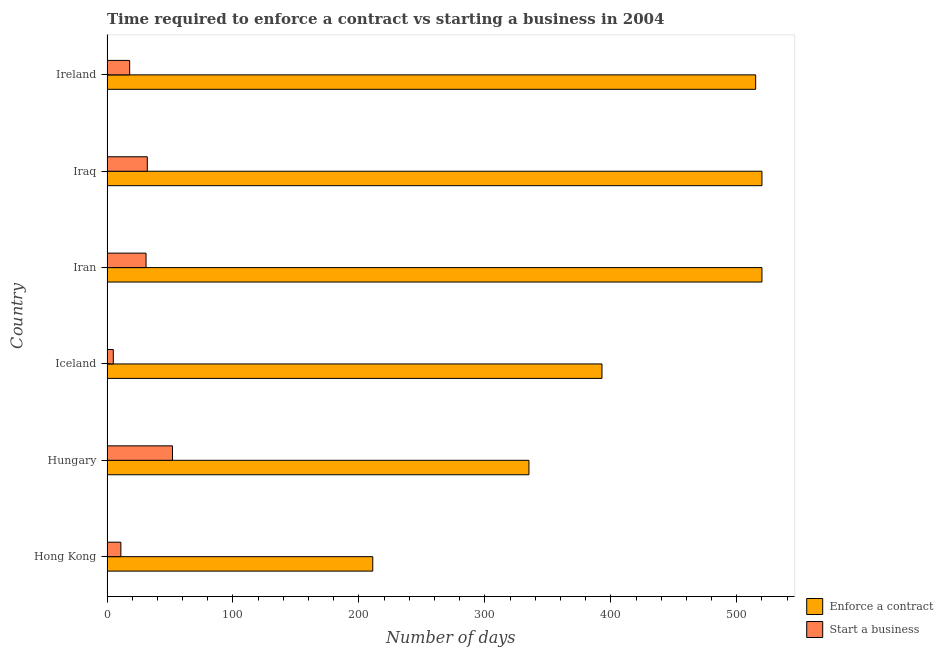How many groups of bars are there?
Your answer should be compact. 6. How many bars are there on the 6th tick from the bottom?
Your answer should be very brief. 2. What is the label of the 5th group of bars from the top?
Make the answer very short. Hungary. Across all countries, what is the maximum number of days to enforece a contract?
Ensure brevity in your answer.  520. Across all countries, what is the minimum number of days to enforece a contract?
Your answer should be compact. 211. In which country was the number of days to start a business maximum?
Provide a succinct answer. Hungary. In which country was the number of days to enforece a contract minimum?
Ensure brevity in your answer.  Hong Kong. What is the total number of days to enforece a contract in the graph?
Keep it short and to the point. 2494. What is the difference between the number of days to start a business in Iceland and the number of days to enforece a contract in Iraq?
Make the answer very short. -515. What is the average number of days to enforece a contract per country?
Keep it short and to the point. 415.67. What is the difference between the number of days to start a business and number of days to enforece a contract in Iceland?
Offer a very short reply. -388. In how many countries, is the number of days to start a business greater than 500 days?
Your answer should be compact. 0. What is the ratio of the number of days to enforece a contract in Hong Kong to that in Iran?
Ensure brevity in your answer.  0.41. Is the number of days to start a business in Iceland less than that in Iraq?
Make the answer very short. Yes. In how many countries, is the number of days to start a business greater than the average number of days to start a business taken over all countries?
Give a very brief answer. 3. Is the sum of the number of days to start a business in Hong Kong and Iceland greater than the maximum number of days to enforece a contract across all countries?
Provide a short and direct response. No. What does the 1st bar from the top in Hungary represents?
Ensure brevity in your answer.  Start a business. What does the 2nd bar from the bottom in Hungary represents?
Provide a short and direct response. Start a business. How many bars are there?
Your response must be concise. 12. Are all the bars in the graph horizontal?
Ensure brevity in your answer.  Yes. What is the difference between two consecutive major ticks on the X-axis?
Your answer should be very brief. 100. Are the values on the major ticks of X-axis written in scientific E-notation?
Ensure brevity in your answer.  No. Does the graph contain grids?
Give a very brief answer. No. Where does the legend appear in the graph?
Your answer should be compact. Bottom right. How are the legend labels stacked?
Provide a succinct answer. Vertical. What is the title of the graph?
Offer a very short reply. Time required to enforce a contract vs starting a business in 2004. Does "Overweight" appear as one of the legend labels in the graph?
Give a very brief answer. No. What is the label or title of the X-axis?
Your answer should be very brief. Number of days. What is the Number of days in Enforce a contract in Hong Kong?
Your answer should be compact. 211. What is the Number of days of Enforce a contract in Hungary?
Make the answer very short. 335. What is the Number of days in Start a business in Hungary?
Your answer should be very brief. 52. What is the Number of days in Enforce a contract in Iceland?
Provide a short and direct response. 393. What is the Number of days in Enforce a contract in Iran?
Ensure brevity in your answer.  520. What is the Number of days in Start a business in Iran?
Your response must be concise. 31. What is the Number of days in Enforce a contract in Iraq?
Offer a terse response. 520. What is the Number of days in Start a business in Iraq?
Provide a succinct answer. 32. What is the Number of days of Enforce a contract in Ireland?
Your response must be concise. 515. What is the Number of days in Start a business in Ireland?
Offer a terse response. 18. Across all countries, what is the maximum Number of days of Enforce a contract?
Give a very brief answer. 520. Across all countries, what is the minimum Number of days of Enforce a contract?
Provide a succinct answer. 211. What is the total Number of days of Enforce a contract in the graph?
Keep it short and to the point. 2494. What is the total Number of days of Start a business in the graph?
Offer a very short reply. 149. What is the difference between the Number of days in Enforce a contract in Hong Kong and that in Hungary?
Your answer should be very brief. -124. What is the difference between the Number of days of Start a business in Hong Kong and that in Hungary?
Keep it short and to the point. -41. What is the difference between the Number of days in Enforce a contract in Hong Kong and that in Iceland?
Ensure brevity in your answer.  -182. What is the difference between the Number of days of Start a business in Hong Kong and that in Iceland?
Offer a terse response. 6. What is the difference between the Number of days in Enforce a contract in Hong Kong and that in Iran?
Provide a short and direct response. -309. What is the difference between the Number of days of Enforce a contract in Hong Kong and that in Iraq?
Ensure brevity in your answer.  -309. What is the difference between the Number of days in Enforce a contract in Hong Kong and that in Ireland?
Ensure brevity in your answer.  -304. What is the difference between the Number of days in Start a business in Hong Kong and that in Ireland?
Give a very brief answer. -7. What is the difference between the Number of days of Enforce a contract in Hungary and that in Iceland?
Ensure brevity in your answer.  -58. What is the difference between the Number of days of Enforce a contract in Hungary and that in Iran?
Provide a succinct answer. -185. What is the difference between the Number of days of Start a business in Hungary and that in Iran?
Provide a succinct answer. 21. What is the difference between the Number of days in Enforce a contract in Hungary and that in Iraq?
Offer a terse response. -185. What is the difference between the Number of days in Start a business in Hungary and that in Iraq?
Your answer should be compact. 20. What is the difference between the Number of days of Enforce a contract in Hungary and that in Ireland?
Offer a terse response. -180. What is the difference between the Number of days in Start a business in Hungary and that in Ireland?
Your response must be concise. 34. What is the difference between the Number of days of Enforce a contract in Iceland and that in Iran?
Ensure brevity in your answer.  -127. What is the difference between the Number of days of Enforce a contract in Iceland and that in Iraq?
Your answer should be very brief. -127. What is the difference between the Number of days of Enforce a contract in Iceland and that in Ireland?
Provide a short and direct response. -122. What is the difference between the Number of days in Start a business in Iceland and that in Ireland?
Your response must be concise. -13. What is the difference between the Number of days of Enforce a contract in Iran and that in Ireland?
Give a very brief answer. 5. What is the difference between the Number of days in Enforce a contract in Hong Kong and the Number of days in Start a business in Hungary?
Give a very brief answer. 159. What is the difference between the Number of days in Enforce a contract in Hong Kong and the Number of days in Start a business in Iceland?
Provide a short and direct response. 206. What is the difference between the Number of days of Enforce a contract in Hong Kong and the Number of days of Start a business in Iran?
Your response must be concise. 180. What is the difference between the Number of days of Enforce a contract in Hong Kong and the Number of days of Start a business in Iraq?
Provide a succinct answer. 179. What is the difference between the Number of days of Enforce a contract in Hong Kong and the Number of days of Start a business in Ireland?
Your answer should be very brief. 193. What is the difference between the Number of days of Enforce a contract in Hungary and the Number of days of Start a business in Iceland?
Give a very brief answer. 330. What is the difference between the Number of days of Enforce a contract in Hungary and the Number of days of Start a business in Iran?
Offer a very short reply. 304. What is the difference between the Number of days in Enforce a contract in Hungary and the Number of days in Start a business in Iraq?
Your answer should be compact. 303. What is the difference between the Number of days of Enforce a contract in Hungary and the Number of days of Start a business in Ireland?
Your answer should be compact. 317. What is the difference between the Number of days in Enforce a contract in Iceland and the Number of days in Start a business in Iran?
Make the answer very short. 362. What is the difference between the Number of days of Enforce a contract in Iceland and the Number of days of Start a business in Iraq?
Ensure brevity in your answer.  361. What is the difference between the Number of days in Enforce a contract in Iceland and the Number of days in Start a business in Ireland?
Make the answer very short. 375. What is the difference between the Number of days in Enforce a contract in Iran and the Number of days in Start a business in Iraq?
Your answer should be compact. 488. What is the difference between the Number of days of Enforce a contract in Iran and the Number of days of Start a business in Ireland?
Your answer should be compact. 502. What is the difference between the Number of days in Enforce a contract in Iraq and the Number of days in Start a business in Ireland?
Offer a terse response. 502. What is the average Number of days in Enforce a contract per country?
Your response must be concise. 415.67. What is the average Number of days of Start a business per country?
Offer a terse response. 24.83. What is the difference between the Number of days in Enforce a contract and Number of days in Start a business in Hungary?
Offer a terse response. 283. What is the difference between the Number of days of Enforce a contract and Number of days of Start a business in Iceland?
Give a very brief answer. 388. What is the difference between the Number of days of Enforce a contract and Number of days of Start a business in Iran?
Offer a terse response. 489. What is the difference between the Number of days in Enforce a contract and Number of days in Start a business in Iraq?
Your answer should be very brief. 488. What is the difference between the Number of days of Enforce a contract and Number of days of Start a business in Ireland?
Offer a terse response. 497. What is the ratio of the Number of days of Enforce a contract in Hong Kong to that in Hungary?
Your response must be concise. 0.63. What is the ratio of the Number of days of Start a business in Hong Kong to that in Hungary?
Your answer should be compact. 0.21. What is the ratio of the Number of days in Enforce a contract in Hong Kong to that in Iceland?
Provide a short and direct response. 0.54. What is the ratio of the Number of days of Enforce a contract in Hong Kong to that in Iran?
Provide a succinct answer. 0.41. What is the ratio of the Number of days in Start a business in Hong Kong to that in Iran?
Your response must be concise. 0.35. What is the ratio of the Number of days of Enforce a contract in Hong Kong to that in Iraq?
Your response must be concise. 0.41. What is the ratio of the Number of days in Start a business in Hong Kong to that in Iraq?
Make the answer very short. 0.34. What is the ratio of the Number of days of Enforce a contract in Hong Kong to that in Ireland?
Keep it short and to the point. 0.41. What is the ratio of the Number of days in Start a business in Hong Kong to that in Ireland?
Provide a short and direct response. 0.61. What is the ratio of the Number of days of Enforce a contract in Hungary to that in Iceland?
Give a very brief answer. 0.85. What is the ratio of the Number of days in Start a business in Hungary to that in Iceland?
Your response must be concise. 10.4. What is the ratio of the Number of days of Enforce a contract in Hungary to that in Iran?
Give a very brief answer. 0.64. What is the ratio of the Number of days of Start a business in Hungary to that in Iran?
Make the answer very short. 1.68. What is the ratio of the Number of days in Enforce a contract in Hungary to that in Iraq?
Provide a short and direct response. 0.64. What is the ratio of the Number of days in Start a business in Hungary to that in Iraq?
Offer a terse response. 1.62. What is the ratio of the Number of days in Enforce a contract in Hungary to that in Ireland?
Your answer should be very brief. 0.65. What is the ratio of the Number of days of Start a business in Hungary to that in Ireland?
Your response must be concise. 2.89. What is the ratio of the Number of days of Enforce a contract in Iceland to that in Iran?
Offer a terse response. 0.76. What is the ratio of the Number of days in Start a business in Iceland to that in Iran?
Make the answer very short. 0.16. What is the ratio of the Number of days of Enforce a contract in Iceland to that in Iraq?
Give a very brief answer. 0.76. What is the ratio of the Number of days in Start a business in Iceland to that in Iraq?
Ensure brevity in your answer.  0.16. What is the ratio of the Number of days of Enforce a contract in Iceland to that in Ireland?
Ensure brevity in your answer.  0.76. What is the ratio of the Number of days in Start a business in Iceland to that in Ireland?
Give a very brief answer. 0.28. What is the ratio of the Number of days in Enforce a contract in Iran to that in Iraq?
Make the answer very short. 1. What is the ratio of the Number of days of Start a business in Iran to that in Iraq?
Your response must be concise. 0.97. What is the ratio of the Number of days in Enforce a contract in Iran to that in Ireland?
Provide a short and direct response. 1.01. What is the ratio of the Number of days of Start a business in Iran to that in Ireland?
Offer a very short reply. 1.72. What is the ratio of the Number of days in Enforce a contract in Iraq to that in Ireland?
Offer a terse response. 1.01. What is the ratio of the Number of days in Start a business in Iraq to that in Ireland?
Offer a very short reply. 1.78. What is the difference between the highest and the lowest Number of days of Enforce a contract?
Provide a succinct answer. 309. What is the difference between the highest and the lowest Number of days in Start a business?
Provide a succinct answer. 47. 